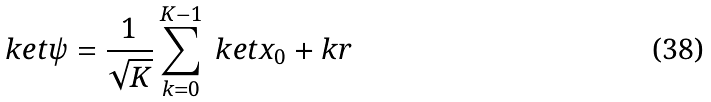Convert formula to latex. <formula><loc_0><loc_0><loc_500><loc_500>\ k e t { \psi } = \frac { 1 } { \sqrt { K } } \sum _ { k = 0 } ^ { K - 1 } \ k e t { x _ { 0 } + k r }</formula> 